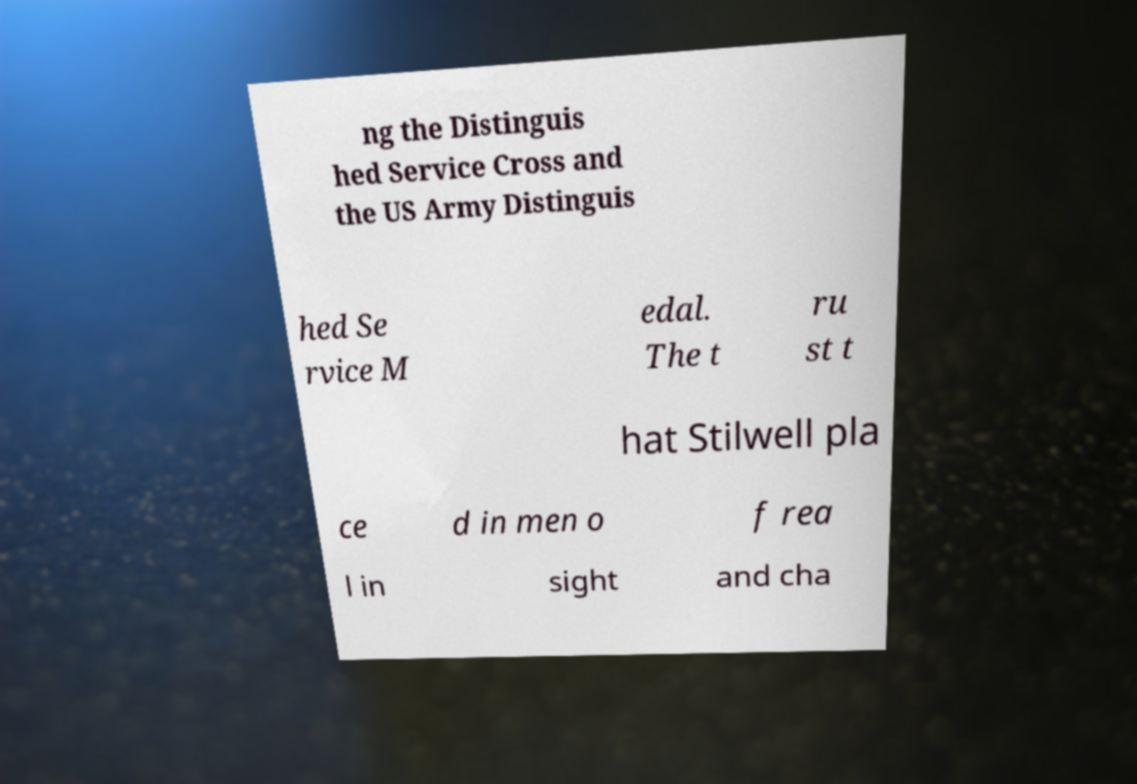Could you assist in decoding the text presented in this image and type it out clearly? ng the Distinguis hed Service Cross and the US Army Distinguis hed Se rvice M edal. The t ru st t hat Stilwell pla ce d in men o f rea l in sight and cha 